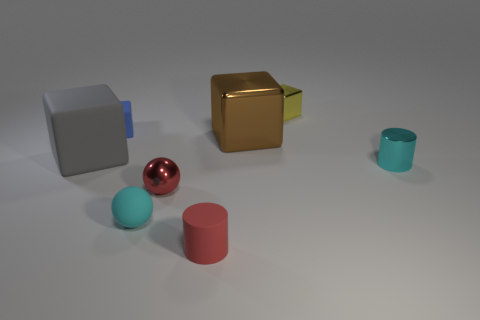Add 2 small yellow shiny blocks. How many objects exist? 10 Subtract all cylinders. How many objects are left? 6 Subtract all small blue objects. Subtract all tiny matte cubes. How many objects are left? 6 Add 2 tiny red matte cylinders. How many tiny red matte cylinders are left? 3 Add 8 metallic balls. How many metallic balls exist? 9 Subtract 0 brown spheres. How many objects are left? 8 